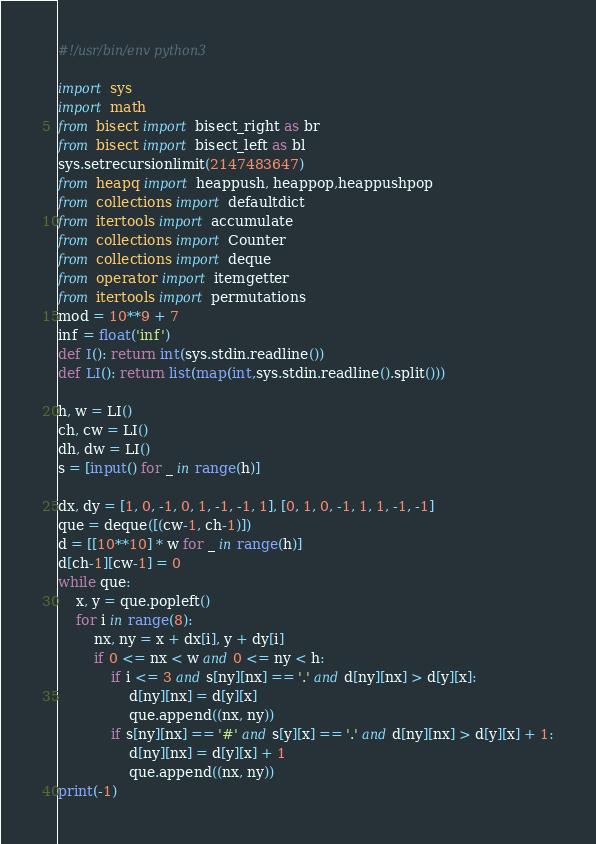<code> <loc_0><loc_0><loc_500><loc_500><_Python_>#!/usr/bin/env python3

import sys
import math
from bisect import bisect_right as br
from bisect import bisect_left as bl
sys.setrecursionlimit(2147483647)
from heapq import heappush, heappop,heappushpop
from collections import defaultdict
from itertools import accumulate
from collections import Counter
from collections import deque
from operator import itemgetter
from itertools import permutations
mod = 10**9 + 7
inf = float('inf')
def I(): return int(sys.stdin.readline())
def LI(): return list(map(int,sys.stdin.readline().split()))

h, w = LI()
ch, cw = LI()
dh, dw = LI()
s = [input() for _ in range(h)]

dx, dy = [1, 0, -1, 0, 1, -1, -1, 1], [0, 1, 0, -1, 1, 1, -1, -1]
que = deque([(cw-1, ch-1)])
d = [[10**10] * w for _ in range(h)]
d[ch-1][cw-1] = 0
while que:
    x, y = que.popleft()
    for i in range(8):
        nx, ny = x + dx[i], y + dy[i]
        if 0 <= nx < w and 0 <= ny < h:
            if i <= 3 and s[ny][nx] == '.' and d[ny][nx] > d[y][x]:
                d[ny][nx] = d[y][x]
                que.append((nx, ny))
            if s[ny][nx] == '#' and s[y][x] == '.' and d[ny][nx] > d[y][x] + 1:
                d[ny][nx] = d[y][x] + 1
                que.append((nx, ny))
print(-1)
</code> 